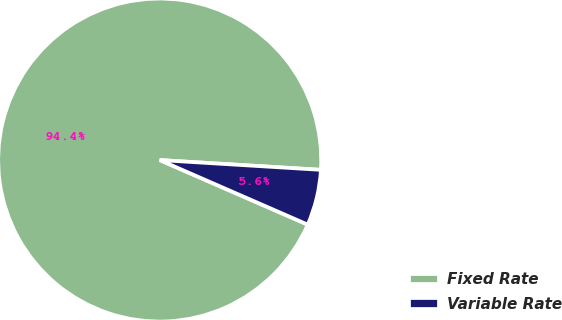Convert chart to OTSL. <chart><loc_0><loc_0><loc_500><loc_500><pie_chart><fcel>Fixed Rate<fcel>Variable Rate<nl><fcel>94.42%<fcel>5.58%<nl></chart> 